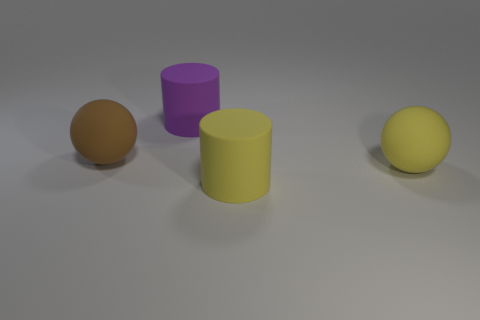Add 3 yellow rubber spheres. How many objects exist? 7 Subtract all purple cylinders. How many cylinders are left? 1 Subtract 0 blue cylinders. How many objects are left? 4 Subtract 2 cylinders. How many cylinders are left? 0 Subtract all cyan balls. Subtract all yellow blocks. How many balls are left? 2 Subtract all gray cylinders. How many brown spheres are left? 1 Subtract all tiny purple matte objects. Subtract all yellow things. How many objects are left? 2 Add 4 brown matte balls. How many brown matte balls are left? 5 Add 1 rubber cylinders. How many rubber cylinders exist? 3 